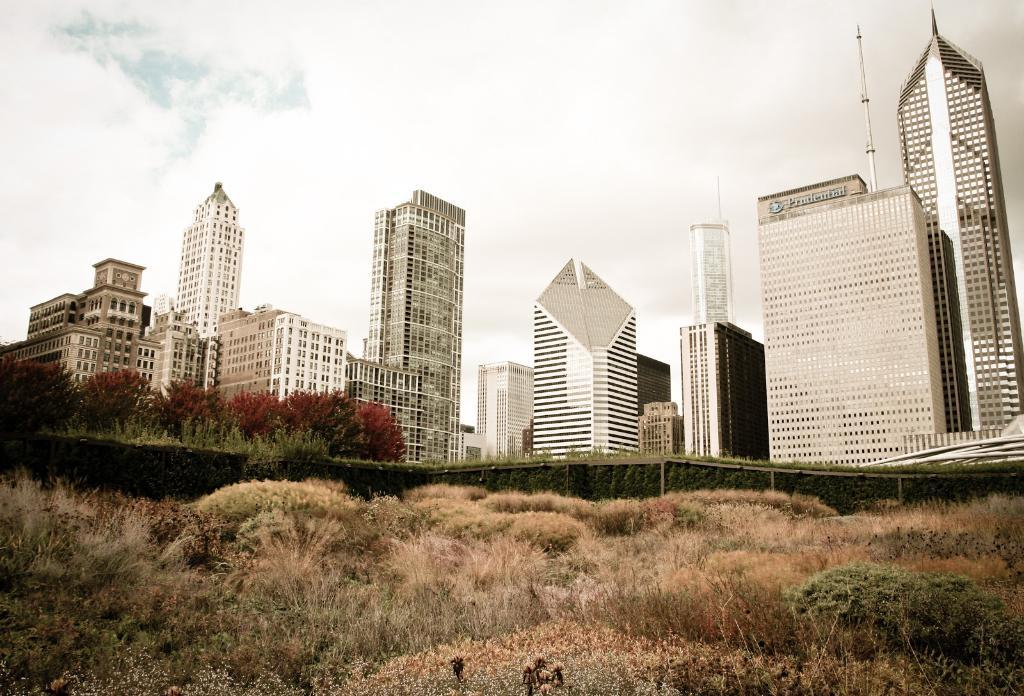What type of structures are present in the image? There are buildings in the image. What type of vegetation can be seen at the bottom of the image? Grass is visible at the bottom of the image. What part of the natural environment is visible in the image? The sky is visible at the top of the image. Where is the girl positioned in the image? There is no girl present in the image. What shape is the square in the image? There is no square present in the image. 